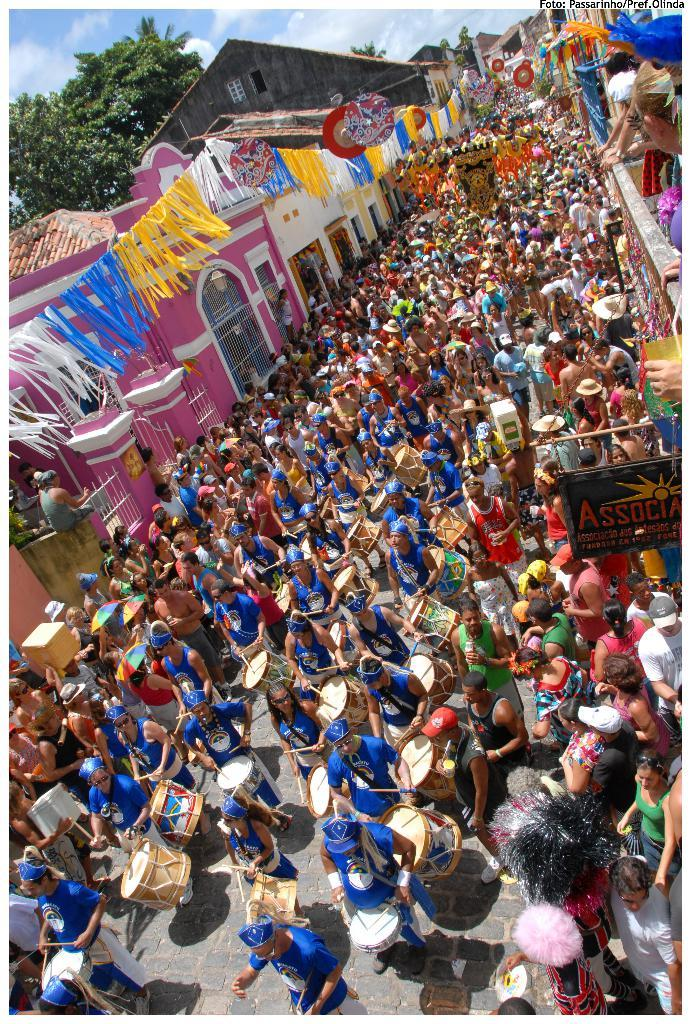What type of event is taking place in the image? There are people participating in a carnival in the image. What are the people doing at the carnival? The people are playing drums and other musical instruments. Where is the carnival taking place? The event is taking place on the road. What can be seen beside the road? There are trees beside the road. What structures are visible in the image? There are buildings visible in the image. What time of day is the carnival taking place, as indicated by the hour on a clock in the image? There is no clock visible in the image, so we cannot determine the time of day from the image. 